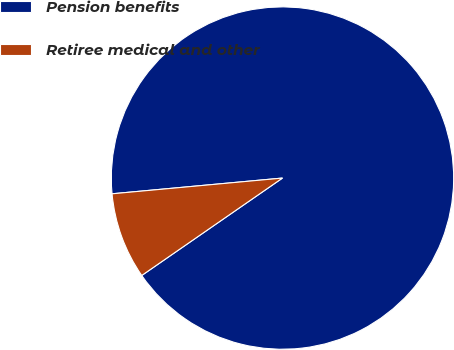<chart> <loc_0><loc_0><loc_500><loc_500><pie_chart><fcel>Pension benefits<fcel>Retiree medical and other<nl><fcel>91.83%<fcel>8.17%<nl></chart> 